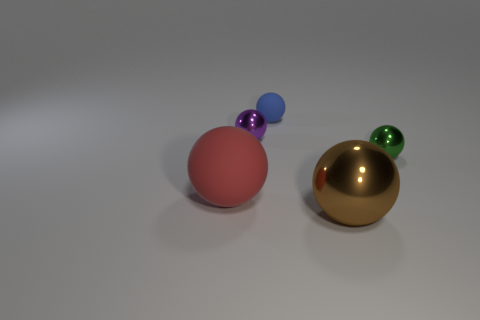What color is the sphere that is to the right of the tiny blue ball and behind the brown metal thing?
Your answer should be compact. Green. How many other objects are the same shape as the brown thing?
Provide a short and direct response. 4. There is another matte ball that is the same size as the purple sphere; what color is it?
Give a very brief answer. Blue. The matte ball in front of the blue object is what color?
Your response must be concise. Red. Are there any purple shiny balls in front of the rubber sphere behind the small purple shiny sphere?
Make the answer very short. Yes. There is a purple object; is its shape the same as the shiny object in front of the big red object?
Ensure brevity in your answer.  Yes. What size is the thing that is in front of the green ball and to the left of the blue rubber object?
Give a very brief answer. Large. Is there a purple object that has the same material as the large brown sphere?
Make the answer very short. Yes. What material is the small ball to the right of the big ball that is to the right of the big rubber sphere made of?
Give a very brief answer. Metal. How many large matte spheres are the same color as the large shiny thing?
Ensure brevity in your answer.  0. 